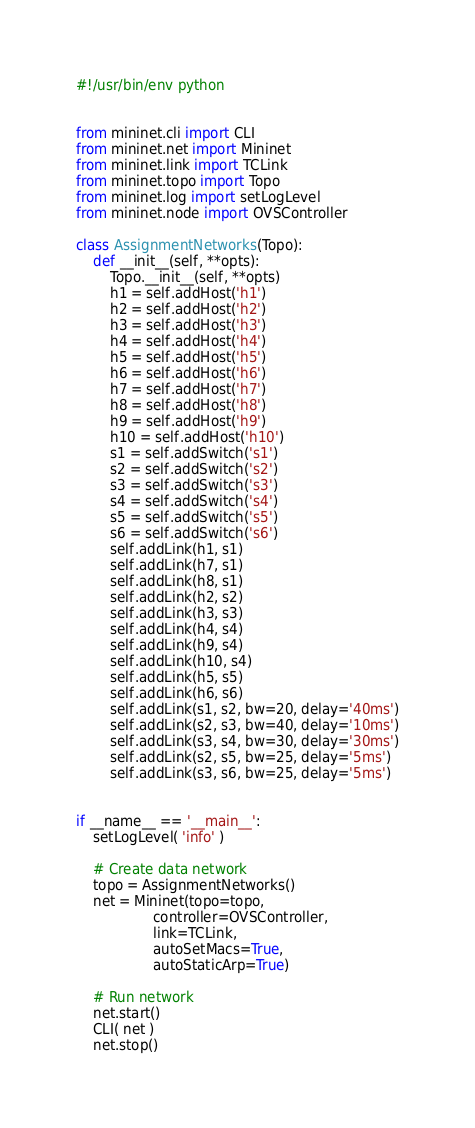Convert code to text. <code><loc_0><loc_0><loc_500><loc_500><_Python_>#!/usr/bin/env python


from mininet.cli import CLI
from mininet.net import Mininet
from mininet.link import TCLink
from mininet.topo import Topo
from mininet.log import setLogLevel
from mininet.node import OVSController

class AssignmentNetworks(Topo):
    def __init__(self, **opts):
        Topo.__init__(self, **opts)
        h1 = self.addHost('h1')
        h2 = self.addHost('h2')
        h3 = self.addHost('h3')
        h4 = self.addHost('h4')
        h5 = self.addHost('h5')
        h6 = self.addHost('h6')
        h7 = self.addHost('h7')
        h8 = self.addHost('h8')
        h9 = self.addHost('h9')
        h10 = self.addHost('h10')
        s1 = self.addSwitch('s1')
        s2 = self.addSwitch('s2')
        s3 = self.addSwitch('s3')
        s4 = self.addSwitch('s4')
        s5 = self.addSwitch('s5')
        s6 = self.addSwitch('s6')
        self.addLink(h1, s1)
        self.addLink(h7, s1)
        self.addLink(h8, s1)
        self.addLink(h2, s2)
        self.addLink(h3, s3)
        self.addLink(h4, s4)
        self.addLink(h9, s4)
        self.addLink(h10, s4)
        self.addLink(h5, s5)
        self.addLink(h6, s6)
        self.addLink(s1, s2, bw=20, delay='40ms')
        self.addLink(s2, s3, bw=40, delay='10ms')
        self.addLink(s3, s4, bw=30, delay='30ms')
        self.addLink(s2, s5, bw=25, delay='5ms')
        self.addLink(s3, s6, bw=25, delay='5ms')
        
        
if __name__ == '__main__':
    setLogLevel( 'info' )

    # Create data network
    topo = AssignmentNetworks()
    net = Mininet(topo=topo,
                  controller=OVSController,
                  link=TCLink,
                  autoSetMacs=True,
                  autoStaticArp=True)
    
    # Run network
    net.start()
    CLI( net )
    net.stop()

</code> 